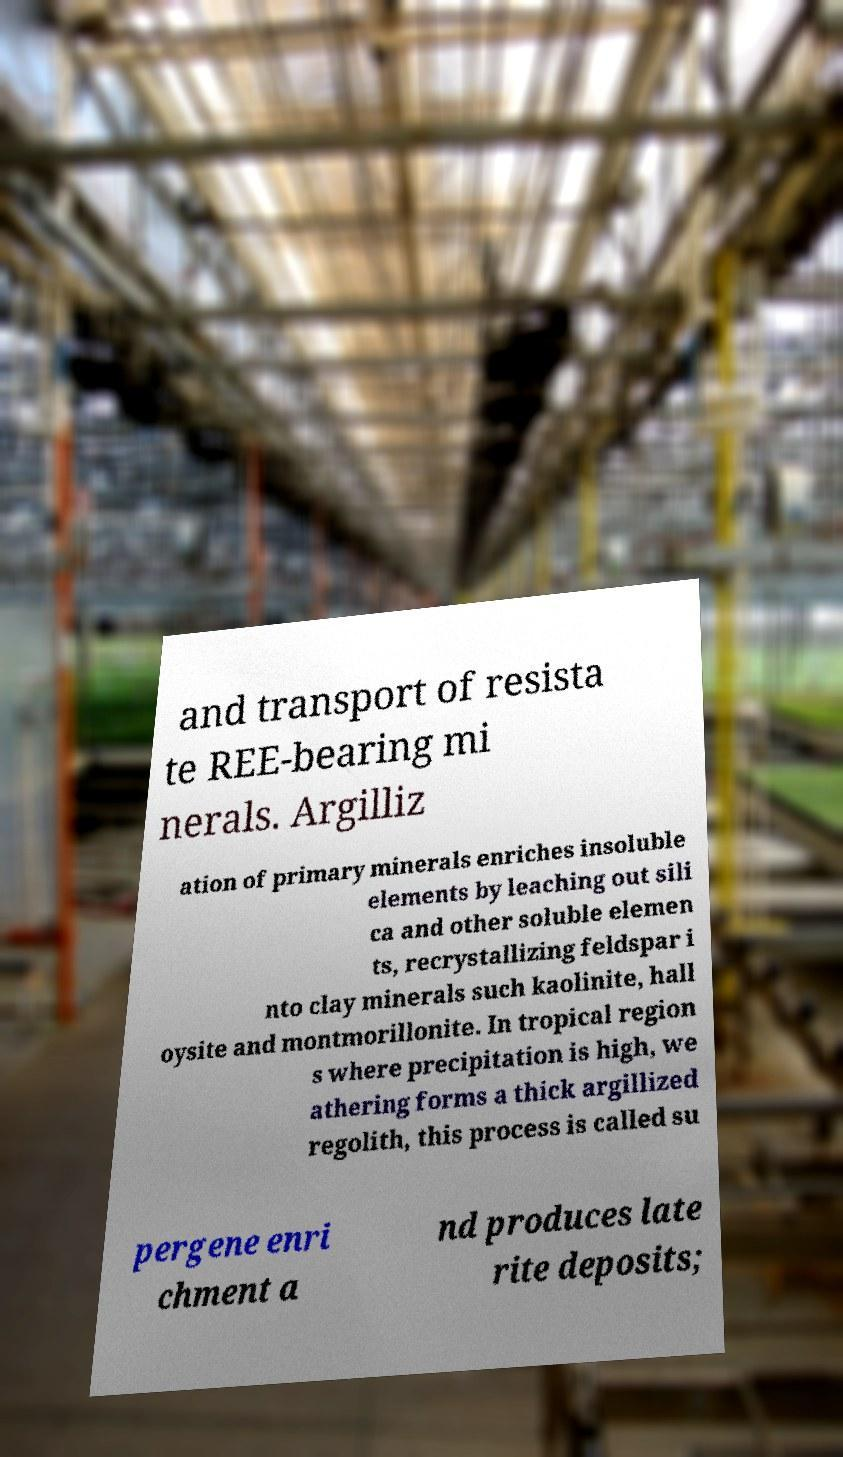I need the written content from this picture converted into text. Can you do that? and transport of resista te REE-bearing mi nerals. Argilliz ation of primary minerals enriches insoluble elements by leaching out sili ca and other soluble elemen ts, recrystallizing feldspar i nto clay minerals such kaolinite, hall oysite and montmorillonite. In tropical region s where precipitation is high, we athering forms a thick argillized regolith, this process is called su pergene enri chment a nd produces late rite deposits; 